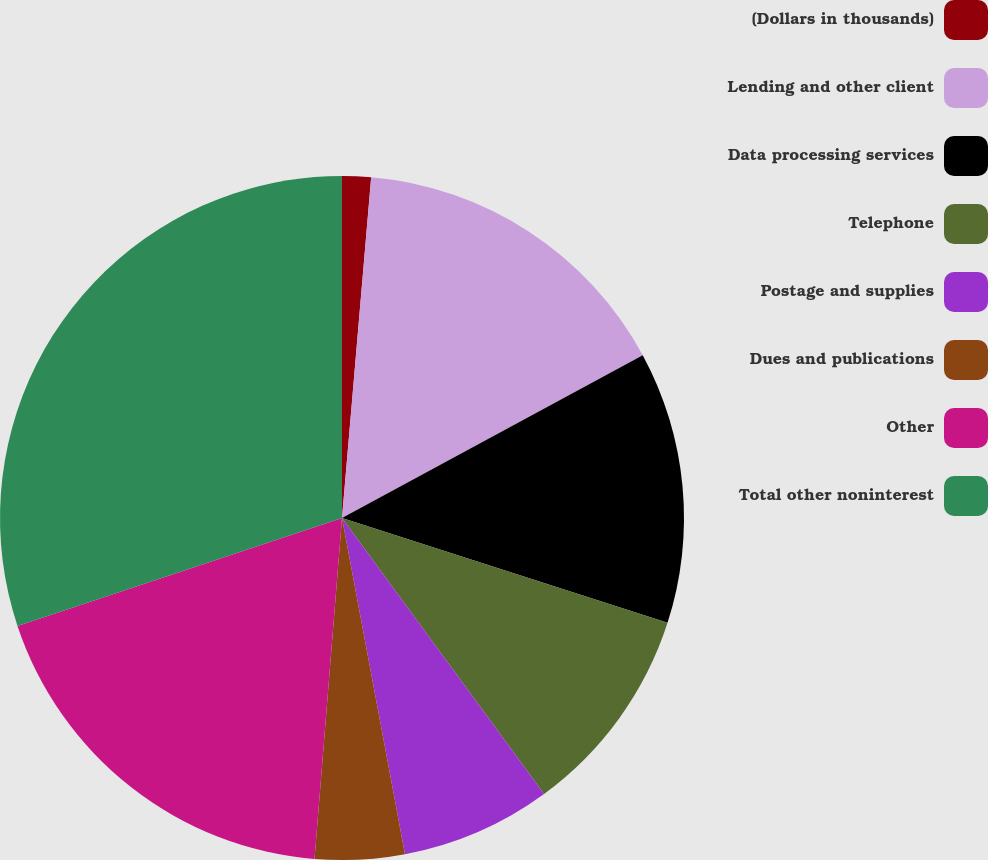Convert chart to OTSL. <chart><loc_0><loc_0><loc_500><loc_500><pie_chart><fcel>(Dollars in thousands)<fcel>Lending and other client<fcel>Data processing services<fcel>Telephone<fcel>Postage and supplies<fcel>Dues and publications<fcel>Other<fcel>Total other noninterest<nl><fcel>1.36%<fcel>15.74%<fcel>12.86%<fcel>9.98%<fcel>7.11%<fcel>4.23%<fcel>18.61%<fcel>30.11%<nl></chart> 